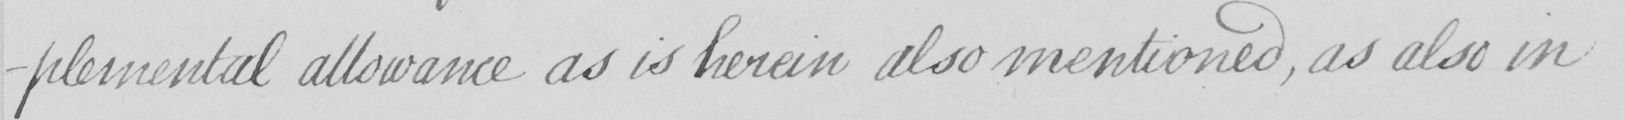What is written in this line of handwriting? -plemental allowance as is herein also mentioned , as also in 